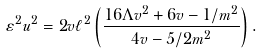Convert formula to latex. <formula><loc_0><loc_0><loc_500><loc_500>\varepsilon ^ { 2 } u ^ { 2 } = 2 v \ell ^ { 2 } \left ( \frac { 1 6 \Lambda v ^ { 2 } + 6 v - 1 / m ^ { 2 } } { 4 v - 5 / 2 m ^ { 2 } } \right ) .</formula> 